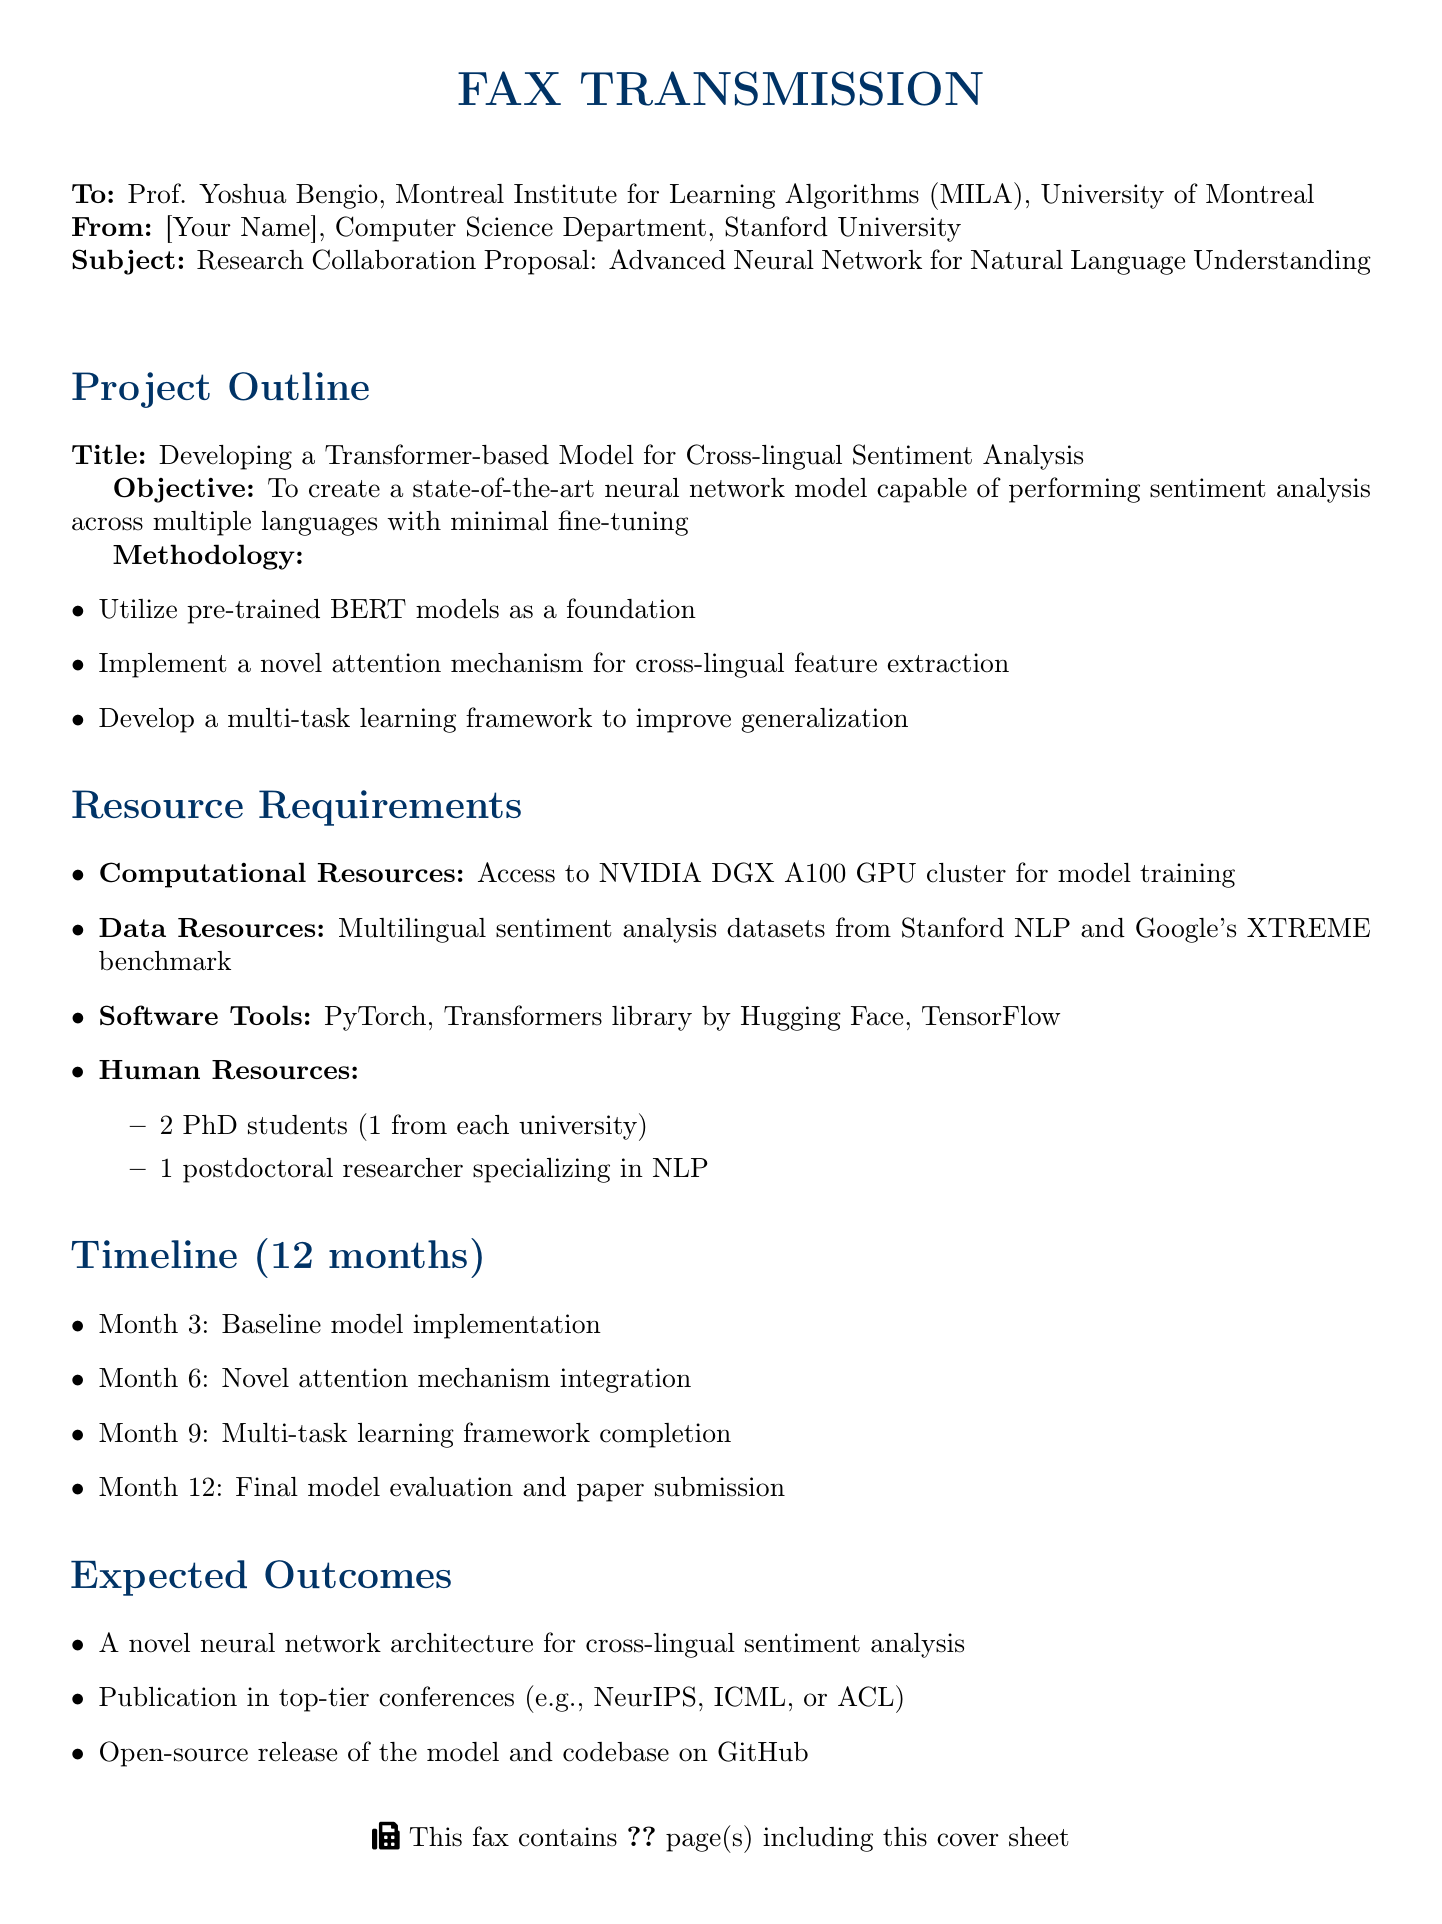What is the project title? The project title is mentioned in the Project Outline section of the document.
Answer: Developing a Transformer-based Model for Cross-lingual Sentiment Analysis Who is the professor the fax is addressed to? The professor's name and institution are stated in the recipient section of the fax.
Answer: Prof. Yoshua Bengio What is the total timeline for the project? The timeline for the project is explicitly mentioned in the Timeline section.
Answer: 12 months How many PhD students are required for the project? The number of PhD students is listed under Human Resources in the Resource Requirements section.
Answer: 2 What is the training architecture used in the project? An architecture used for training is indicated in the Methodology section of the document.
Answer: BERT What is one expected outcome of the project? The expected outcomes are listed in the Expected Outcomes section, which mentions achievements of the project.
Answer: A novel neural network architecture for cross-lingual sentiment analysis Which GPU cluster is required for model training? The specific resources requested for training are detailed in the Resource Requirements section.
Answer: NVIDIA DGX A100 GPU cluster What is the main objective of the project? The objective is outlined in the Project Outline section and expresses the goal of the research.
Answer: To create a state-of-the-art neural network model capable of performing sentiment analysis across multiple languages with minimal fine-tuning What is the methodology focused on? The methodology provides details about the approach being taken for the project, as listed in the Methodology section.
Answer: Attention mechanism for cross-lingual feature extraction 